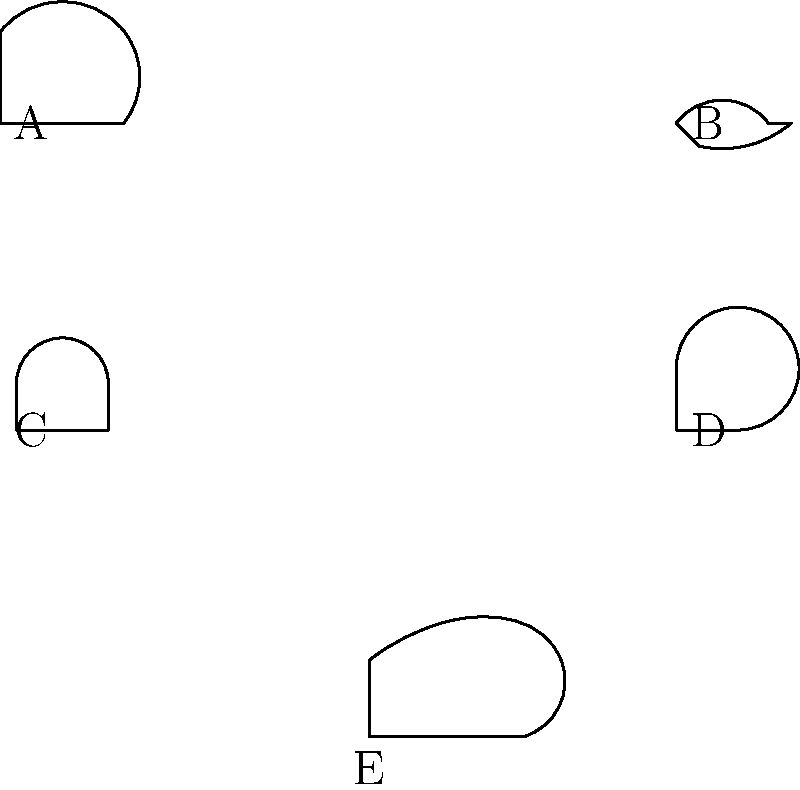As a new factory worker, you are assigned to operate a loud metal cutting machine. Which combination of PPE items, represented by the silhouettes above, should you wear for this task? To determine the correct PPE for operating a loud metal cutting machine, let's consider each item and its purpose:

1. Item A (Top left): This is a hard hat, which protects the head from falling objects. While important in many factory settings, it may not be specifically required for operating a cutting machine.

2. Item B (Top right): These are safety glasses, which protect the eyes from flying debris and sparks. This is essential when operating a metal cutting machine.

3. Item C (Middle left): This represents ear protection, such as earmuffs or earplugs. Given that the machine is described as "loud," this is crucial to protect your hearing.

4. Item D (Middle right): These are gloves, which protect hands from cuts, abrasions, and heat. When handling metal and operating cutting machinery, gloves are necessary.

5. Item E (Bottom center): These are steel-toed boots, which protect feet from heavy falling objects and provide stability. While generally important in a factory setting, they may not be specifically related to operating the cutting machine.

For the task of operating a loud metal cutting machine, the most crucial PPE items are:
- Safety glasses (B) to protect eyes from debris
- Ear protection (C) to guard against loud noise
- Gloves (D) to protect hands while handling metal and operating the machine

Therefore, the correct combination of PPE for this specific task is B, C, and D.
Answer: B, C, D 